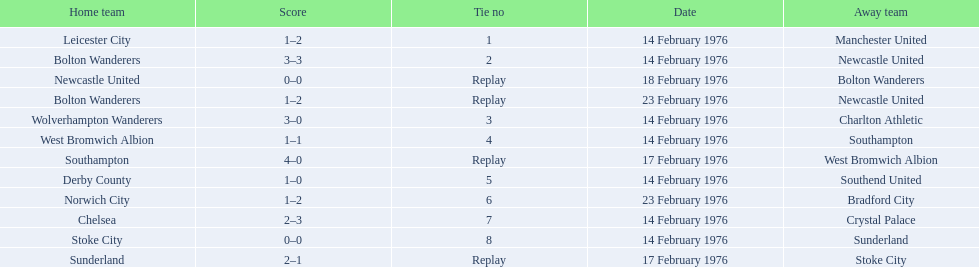What were the home teams in the 1975-76 fa cup? Leicester City, Bolton Wanderers, Newcastle United, Bolton Wanderers, Wolverhampton Wanderers, West Bromwich Albion, Southampton, Derby County, Norwich City, Chelsea, Stoke City, Sunderland. Which of these teams had the tie number 1? Leicester City. Can you give me this table in json format? {'header': ['Home team', 'Score', 'Tie no', 'Date', 'Away team'], 'rows': [['Leicester City', '1–2', '1', '14 February 1976', 'Manchester United'], ['Bolton Wanderers', '3–3', '2', '14 February 1976', 'Newcastle United'], ['Newcastle United', '0–0', 'Replay', '18 February 1976', 'Bolton Wanderers'], ['Bolton Wanderers', '1–2', 'Replay', '23 February 1976', 'Newcastle United'], ['Wolverhampton Wanderers', '3–0', '3', '14 February 1976', 'Charlton Athletic'], ['West Bromwich Albion', '1–1', '4', '14 February 1976', 'Southampton'], ['Southampton', '4–0', 'Replay', '17 February 1976', 'West Bromwich Albion'], ['Derby County', '1–0', '5', '14 February 1976', 'Southend United'], ['Norwich City', '1–2', '6', '23 February 1976', 'Bradford City'], ['Chelsea', '2–3', '7', '14 February 1976', 'Crystal Palace'], ['Stoke City', '0–0', '8', '14 February 1976', 'Sunderland'], ['Sunderland', '2–1', 'Replay', '17 February 1976', 'Stoke City']]} 